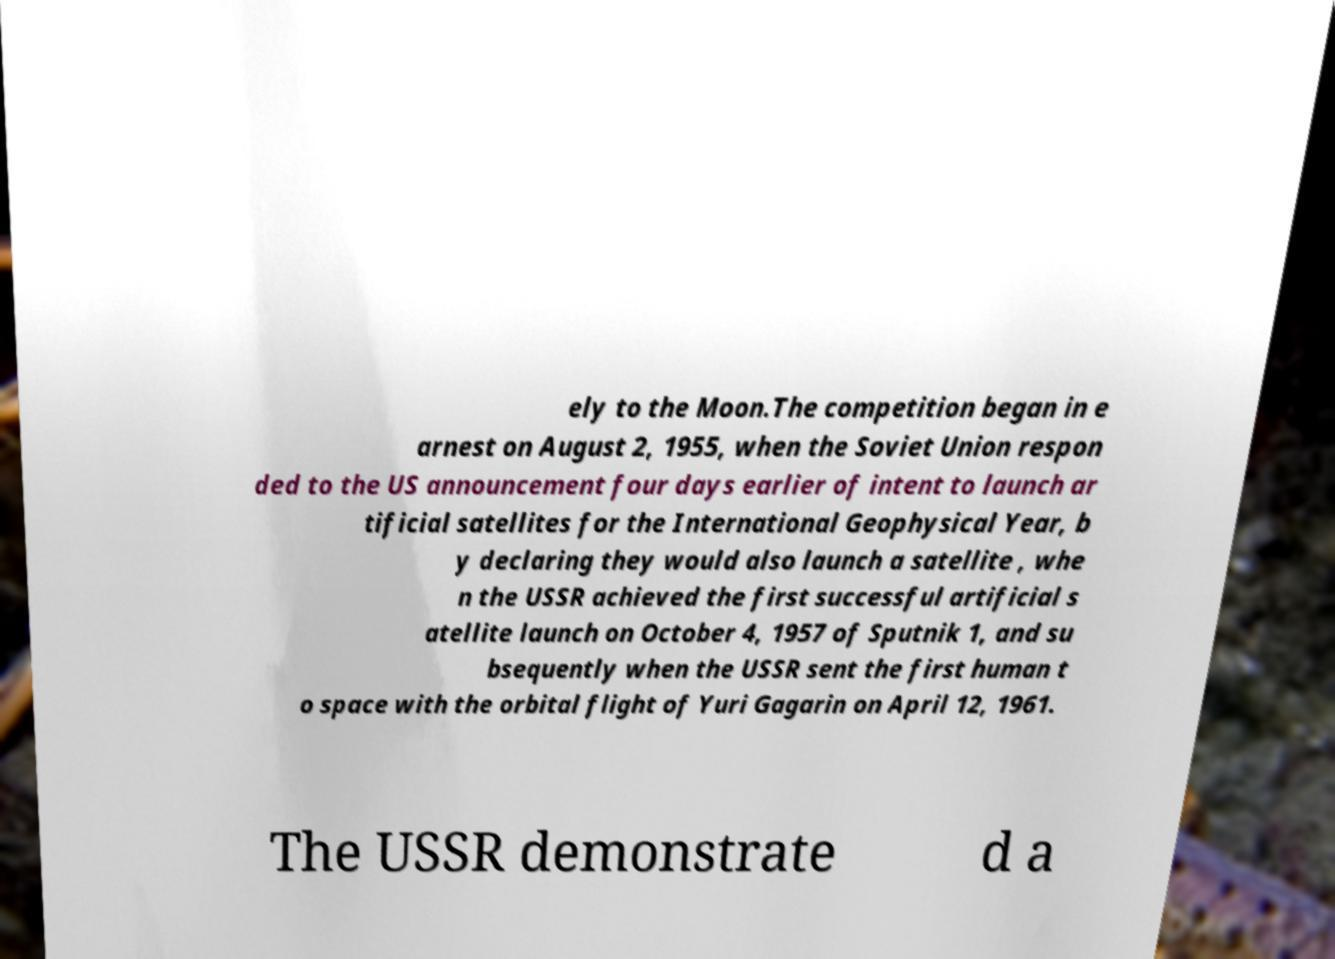There's text embedded in this image that I need extracted. Can you transcribe it verbatim? ely to the Moon.The competition began in e arnest on August 2, 1955, when the Soviet Union respon ded to the US announcement four days earlier of intent to launch ar tificial satellites for the International Geophysical Year, b y declaring they would also launch a satellite , whe n the USSR achieved the first successful artificial s atellite launch on October 4, 1957 of Sputnik 1, and su bsequently when the USSR sent the first human t o space with the orbital flight of Yuri Gagarin on April 12, 1961. The USSR demonstrate d a 